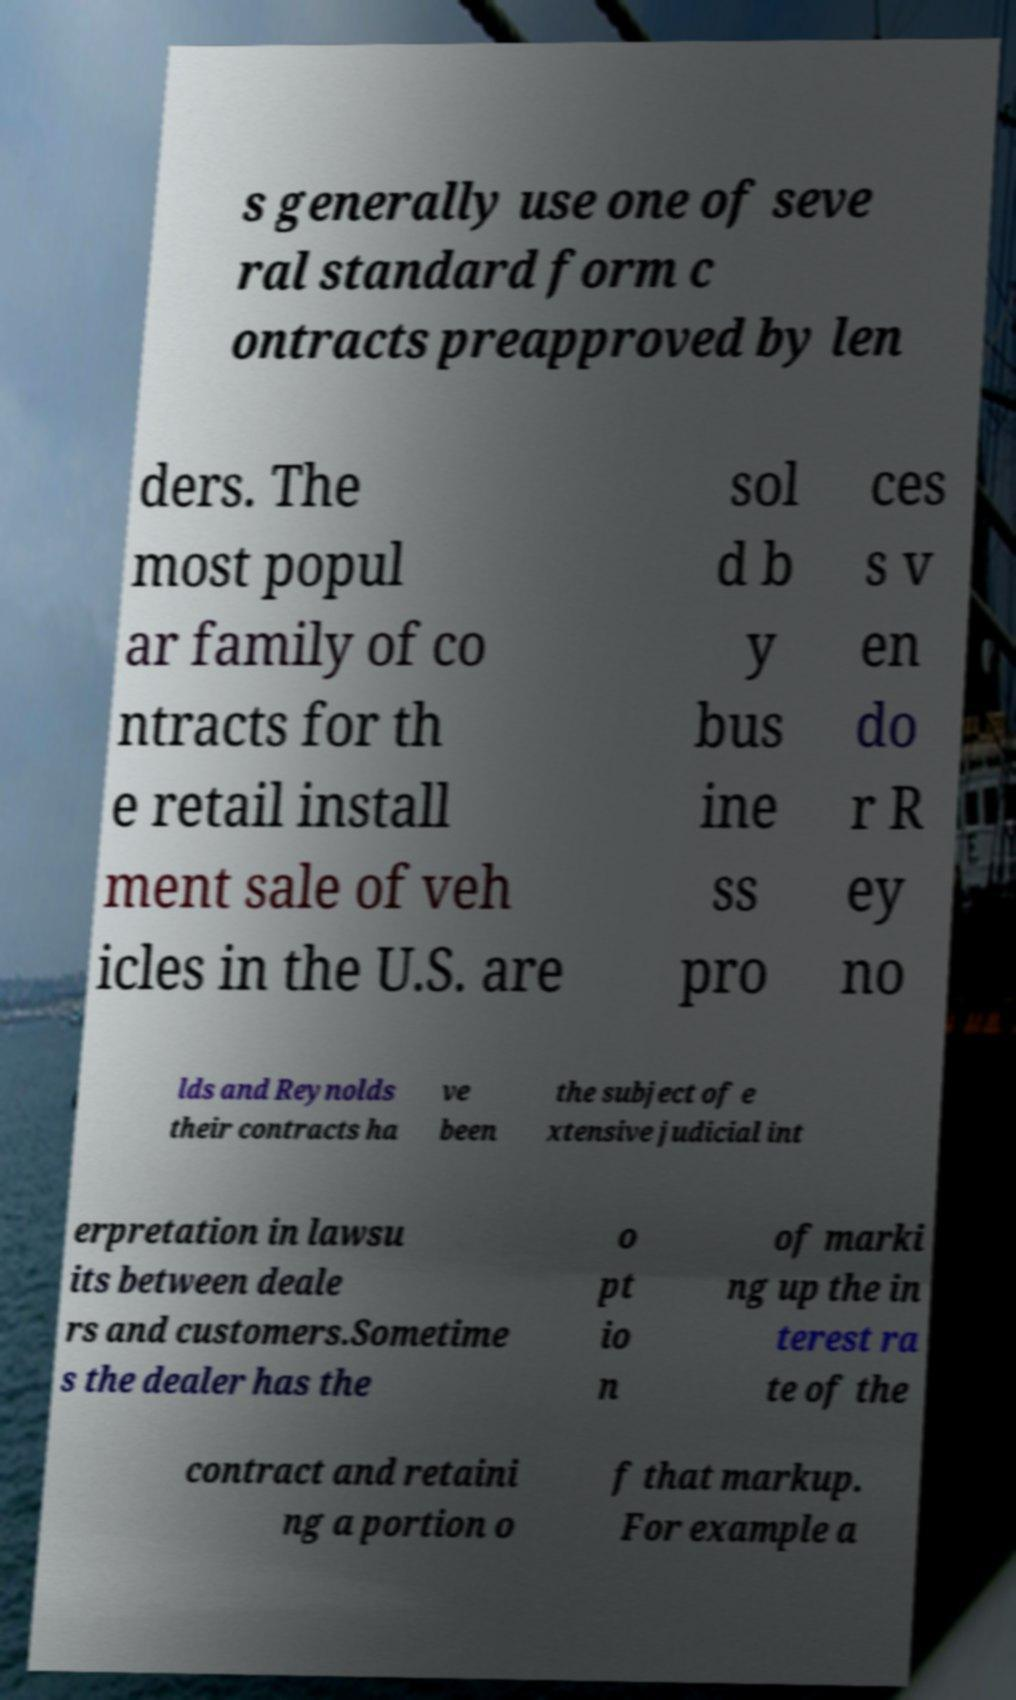Could you extract and type out the text from this image? s generally use one of seve ral standard form c ontracts preapproved by len ders. The most popul ar family of co ntracts for th e retail install ment sale of veh icles in the U.S. are sol d b y bus ine ss pro ces s v en do r R ey no lds and Reynolds their contracts ha ve been the subject of e xtensive judicial int erpretation in lawsu its between deale rs and customers.Sometime s the dealer has the o pt io n of marki ng up the in terest ra te of the contract and retaini ng a portion o f that markup. For example a 